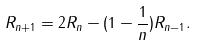Convert formula to latex. <formula><loc_0><loc_0><loc_500><loc_500>R _ { n + 1 } = 2 R _ { n } - ( 1 - { \frac { 1 } { n } } ) R _ { n - 1 } .</formula> 